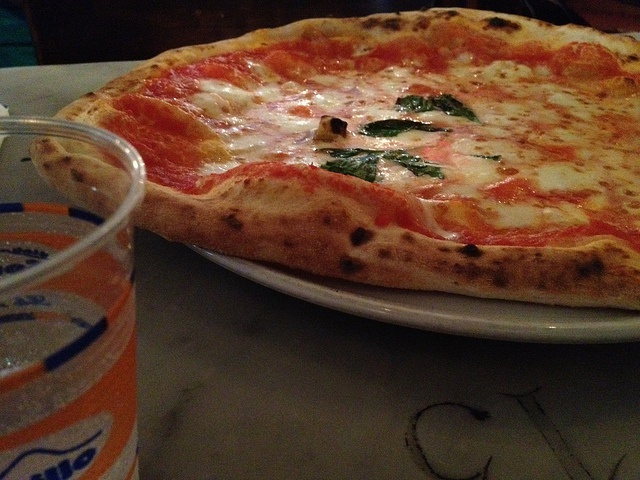Describe the objects in this image and their specific colors. I can see pizza in black, brown, maroon, and gray tones and cup in black, maroon, and gray tones in this image. 